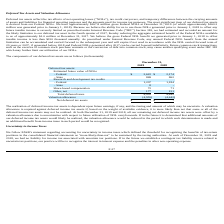According to Acura Pharmaceuticals's financial document, What is the most significant item of the deferred tax assets? The most significant item of our deferred tax assets is derived from our Federal NOLs.. The document states: "oses and the amounts used for income tax purposes. The most significant item of our deferred tax assets is derived from our Federal NOLs. We have appr..." Also, What happens to unused Federal NOL benefit according to Internal Revenue Code? As prescribed under Internal Revenue Code, any unused Federal NOL benefit from the annual limitation can be accumulated and carried forward to the subsequent year and will expire if not used in accordance with the NOL carried forward term of 20 years or 2037, if generated before 2018 and Federal NOLs generated after 2017 can be carried forward indefinitely.. The document states: "axable income is less than $150 thousand annually. As prescribed under Internal Revenue Code, any unused Federal NOL benefit from the annual limitatio..." Also, Why are deferred income tax assets offset in 2018 and 2019? At both December 31, 2019 and 2018, all our remaining net deferred income tax assets were offset by a valuation allowance due to uncertainties with respect to future utilization of NOL carryforwards.. The document states: "he deferred income tax assets may not be realized. At both December 31, 2019 and 2018, all our remaining net deferred income tax assets were offset by..." Also, can you calculate: What is the difference between the total deferred tax in 2018 and 2019? Based on the calculation: 4,955 - 4,442 , the result is 513 (in thousands). This is based on the information: "Total deferred taxes 4,955 4,442 Total deferred taxes 4,955 4,442..." The key data points involved are: 4,442, 4,955. Also, can you calculate: How much did R&D tax credits from the Federal increased from 2018 to 2019? Based on the calculation: 1,207 - 1,184 , the result is 23 (in thousands). This is based on the information: "- Federal 1,207 1,184 - Federal 1,207 1,184..." The key data points involved are: 1,184, 1,207. Also, can you calculate: What is the increase in Net deferred tax assets from 2018 to 2019? I cannot find a specific answer to this question in the financial document. 